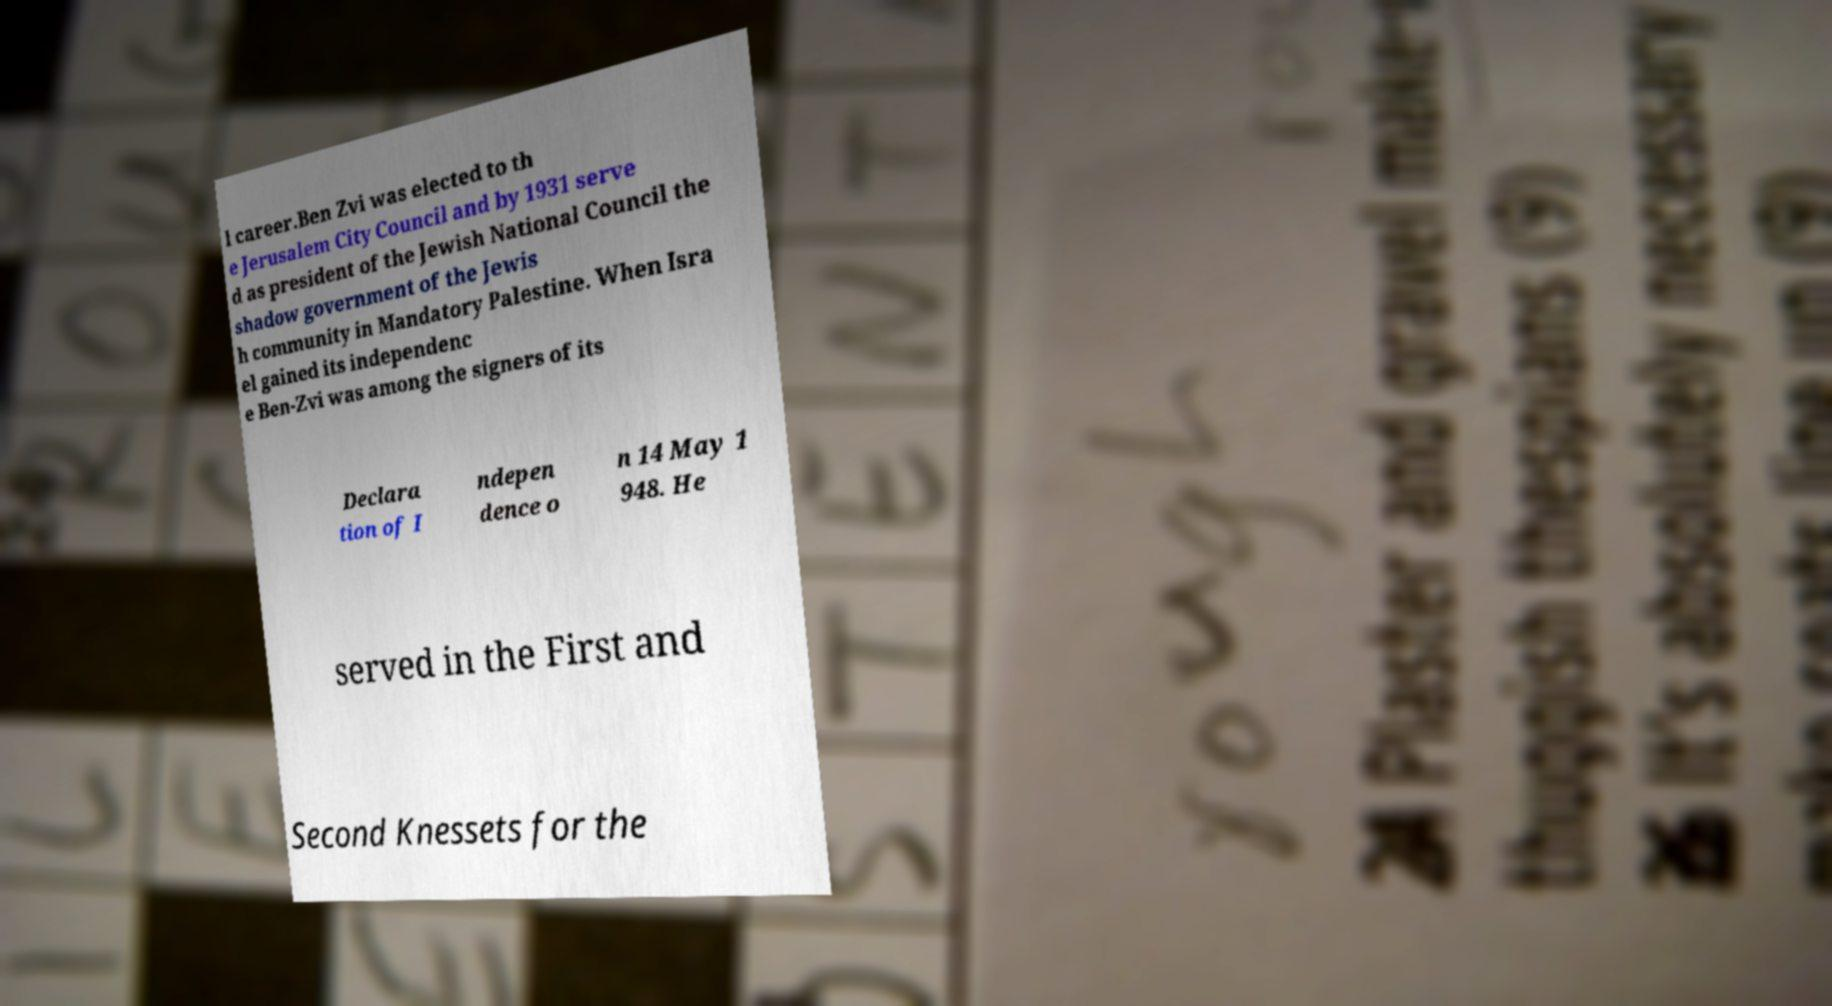Can you accurately transcribe the text from the provided image for me? l career.Ben Zvi was elected to th e Jerusalem City Council and by 1931 serve d as president of the Jewish National Council the shadow government of the Jewis h community in Mandatory Palestine. When Isra el gained its independenc e Ben-Zvi was among the signers of its Declara tion of I ndepen dence o n 14 May 1 948. He served in the First and Second Knessets for the 